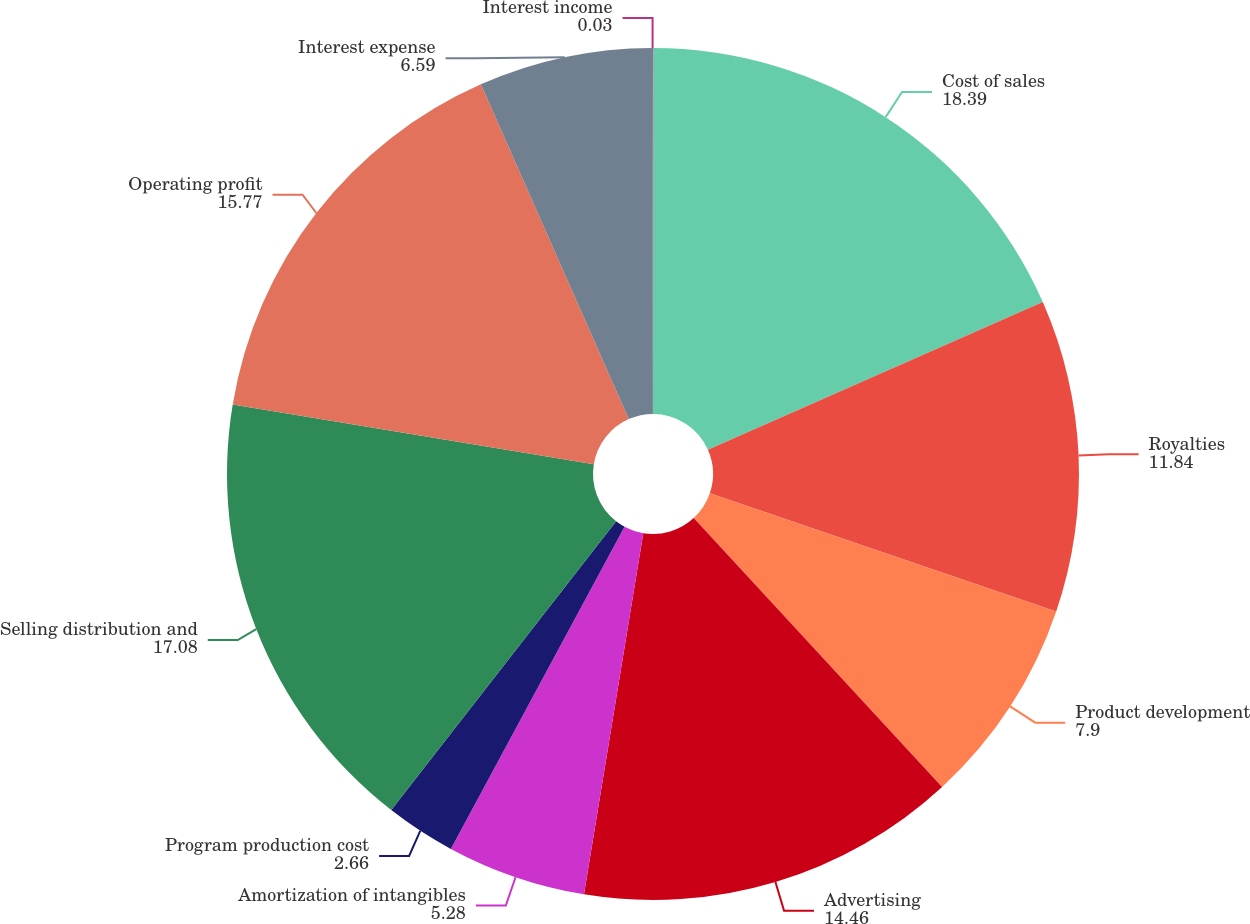Convert chart to OTSL. <chart><loc_0><loc_0><loc_500><loc_500><pie_chart><fcel>Cost of sales<fcel>Royalties<fcel>Product development<fcel>Advertising<fcel>Amortization of intangibles<fcel>Program production cost<fcel>Selling distribution and<fcel>Operating profit<fcel>Interest expense<fcel>Interest income<nl><fcel>18.39%<fcel>11.84%<fcel>7.9%<fcel>14.46%<fcel>5.28%<fcel>2.66%<fcel>17.08%<fcel>15.77%<fcel>6.59%<fcel>0.03%<nl></chart> 